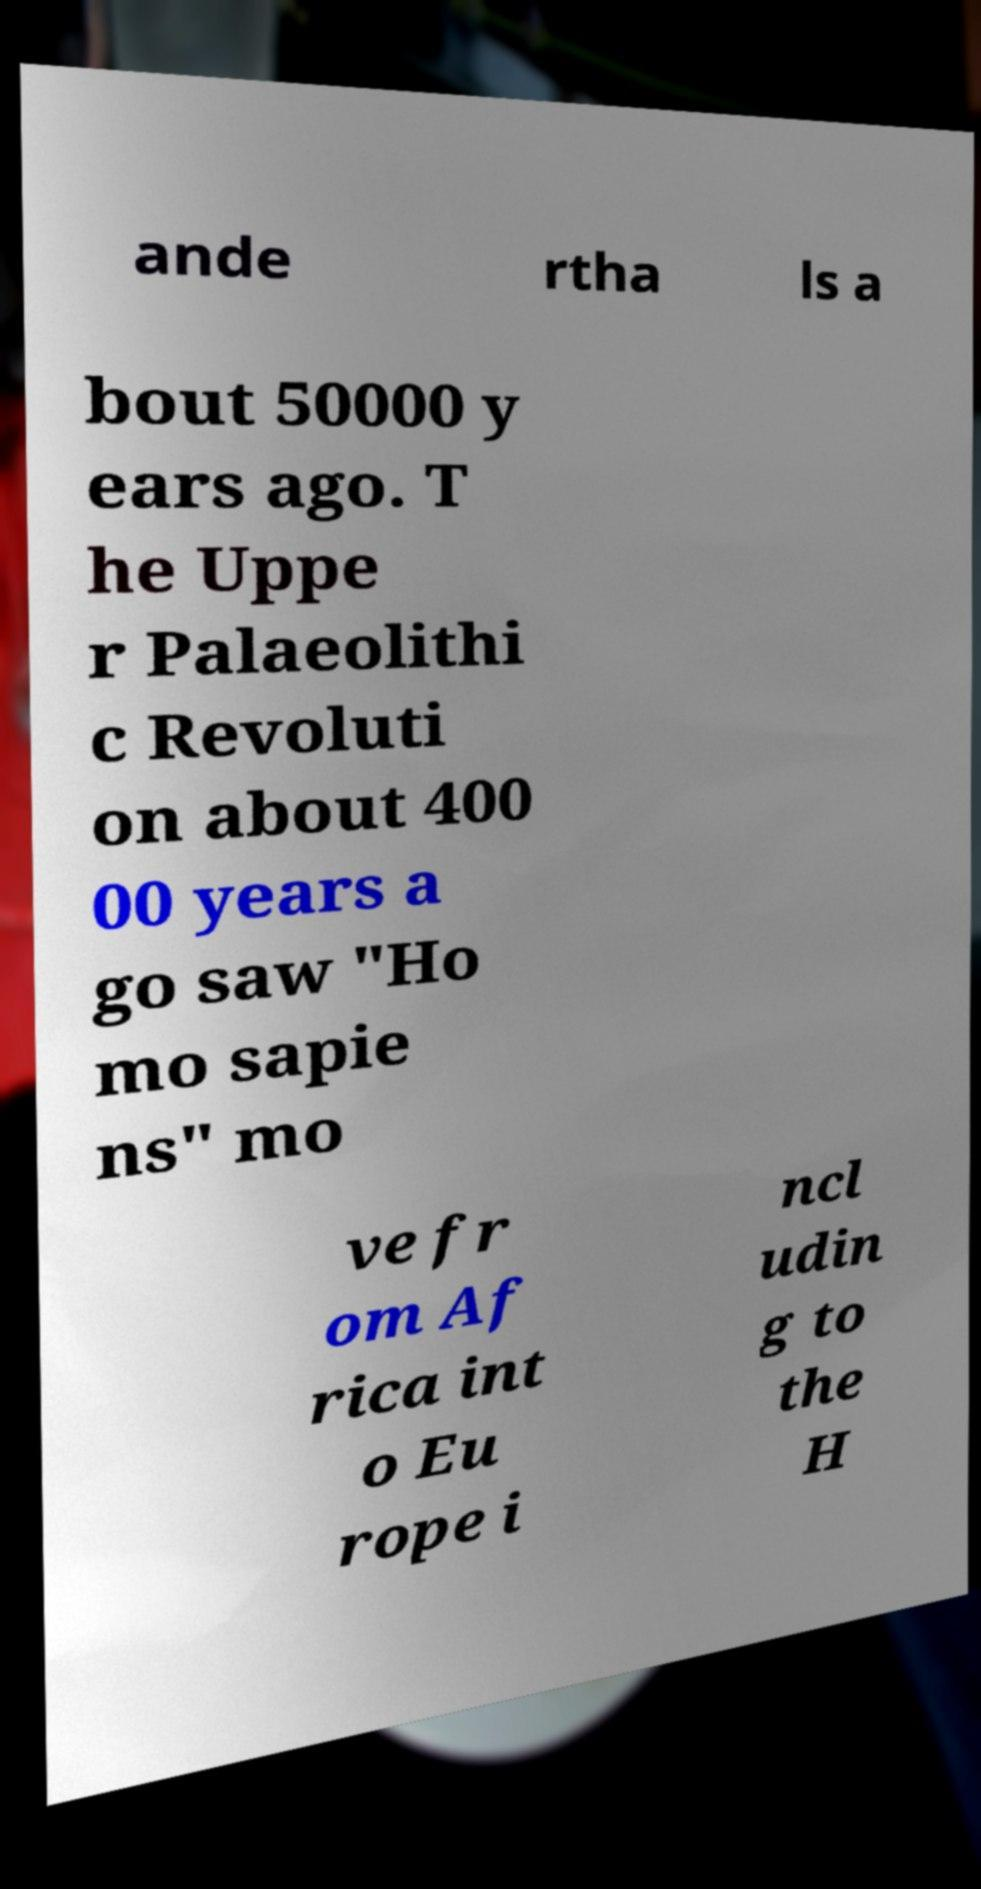Can you read and provide the text displayed in the image?This photo seems to have some interesting text. Can you extract and type it out for me? ande rtha ls a bout 50000 y ears ago. T he Uppe r Palaeolithi c Revoluti on about 400 00 years a go saw "Ho mo sapie ns" mo ve fr om Af rica int o Eu rope i ncl udin g to the H 